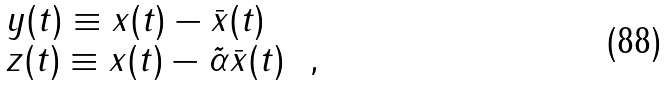<formula> <loc_0><loc_0><loc_500><loc_500>\begin{array} { l l } y ( t ) \equiv x ( t ) - \bar { x } ( t ) \\ z ( t ) \equiv x ( t ) - \tilde { \alpha } \bar { x } ( t ) \ \ , \end{array}</formula> 